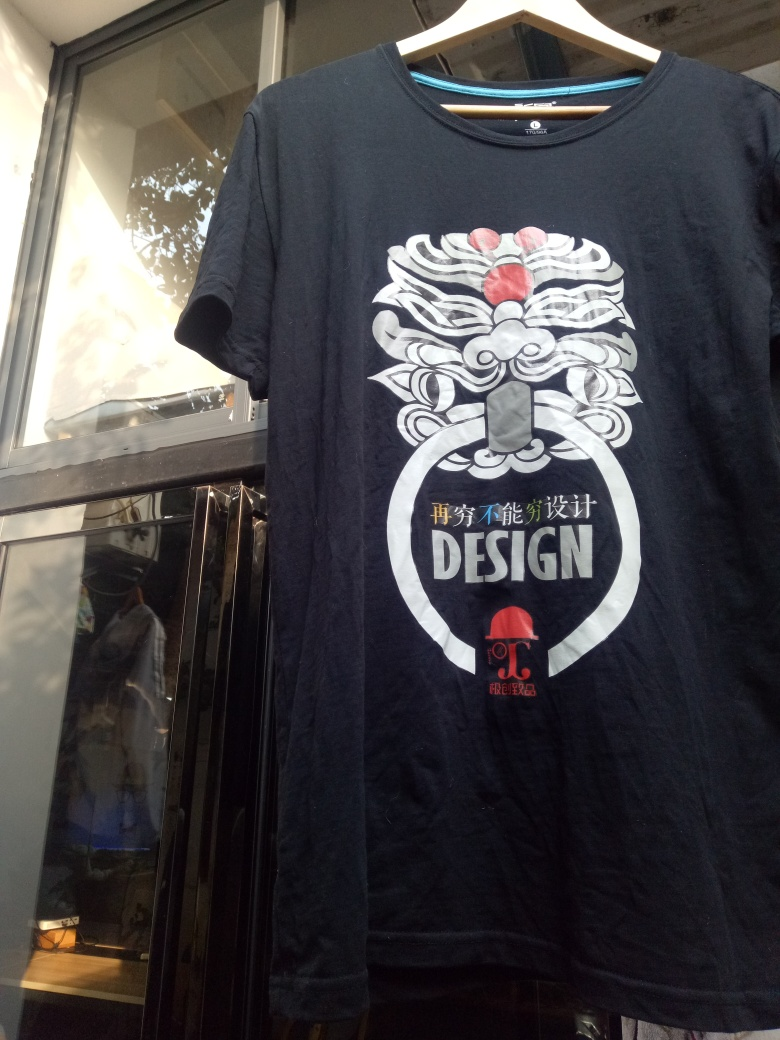What design is printed on the T-shirt? The T-shirt features an intricate illustration of a stylized face, possibly representing a traditional Eastern dragon or lion figure, in white and light gray hues with touches of red. Below the design is the word 'DESIGN' encircled by a curved banner. Just beneath that, there is additional text that appears to be in an East Asian script, potentially branding or detailing the design concept. 